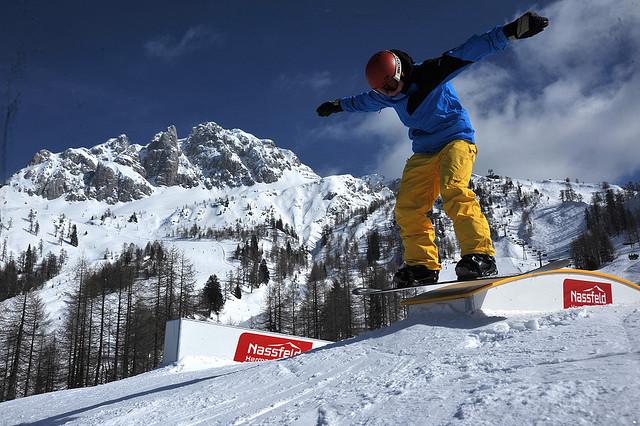IS it summer here?
Give a very brief answer. No. What color are the signs?
Write a very short answer. Red. Is it cold?
Quick response, please. Yes. 